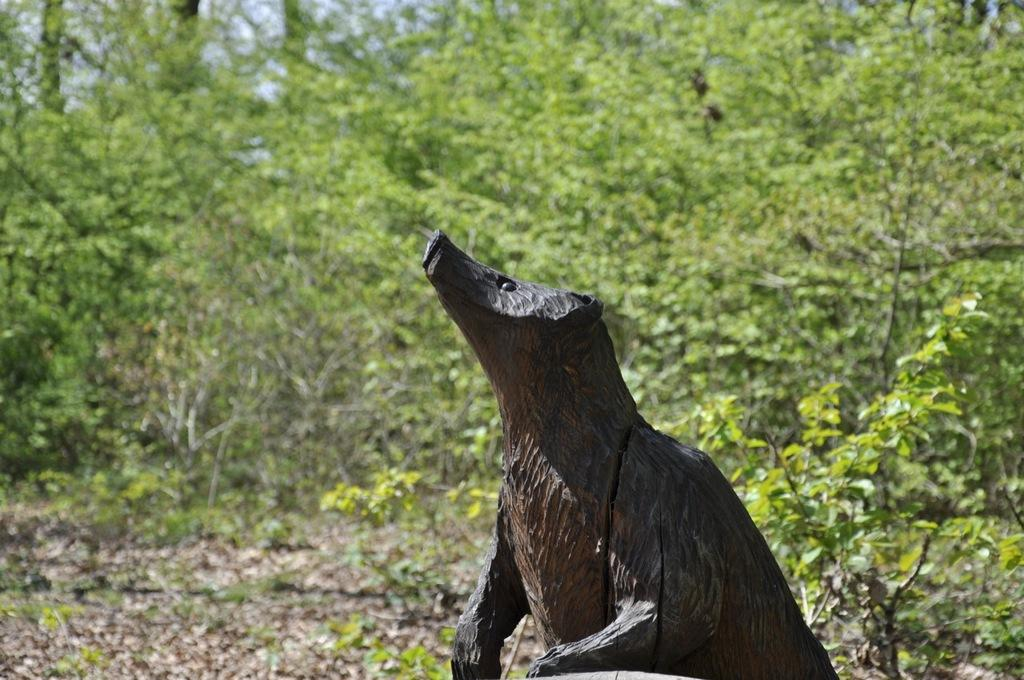What is the main subject in the foreground of the image? There is a sculpture in the foreground of the image. What can be seen in the background of the image? There are trees and grass in the background of the image. What type of fish can be seen swimming in the market in the image? There is no market or fish present in the image; it features a sculpture and natural elements in the background. 